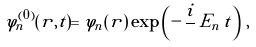<formula> <loc_0><loc_0><loc_500><loc_500>\varphi _ { n } ^ { ( 0 ) } ( { r } , t ) = \varphi _ { n } ( { r } ) \, \exp \left ( - \, \frac { i } { } \, E _ { n } \, t \right ) \, ,</formula> 